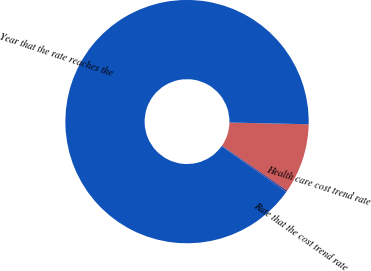<chart> <loc_0><loc_0><loc_500><loc_500><pie_chart><fcel>Health care cost trend rate<fcel>Rate that the cost trend rate<fcel>Year that the rate reaches the<nl><fcel>9.25%<fcel>0.22%<fcel>90.52%<nl></chart> 